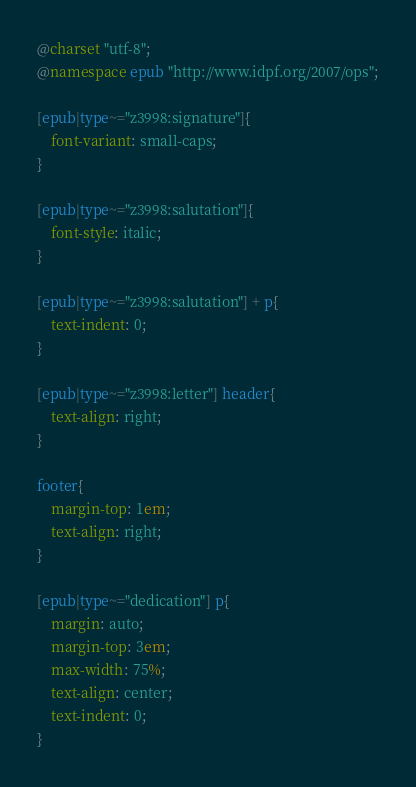<code> <loc_0><loc_0><loc_500><loc_500><_CSS_>@charset "utf-8";
@namespace epub "http://www.idpf.org/2007/ops";

[epub|type~="z3998:signature"]{
	font-variant: small-caps;
}

[epub|type~="z3998:salutation"]{
	font-style: italic;
}

[epub|type~="z3998:salutation"] + p{
	text-indent: 0;
}

[epub|type~="z3998:letter"] header{
	text-align: right;
}

footer{
	margin-top: 1em;
	text-align: right;
}

[epub|type~="dedication"] p{
	margin: auto;
	margin-top: 3em;
	max-width: 75%;
	text-align: center;
	text-indent: 0;
}
</code> 